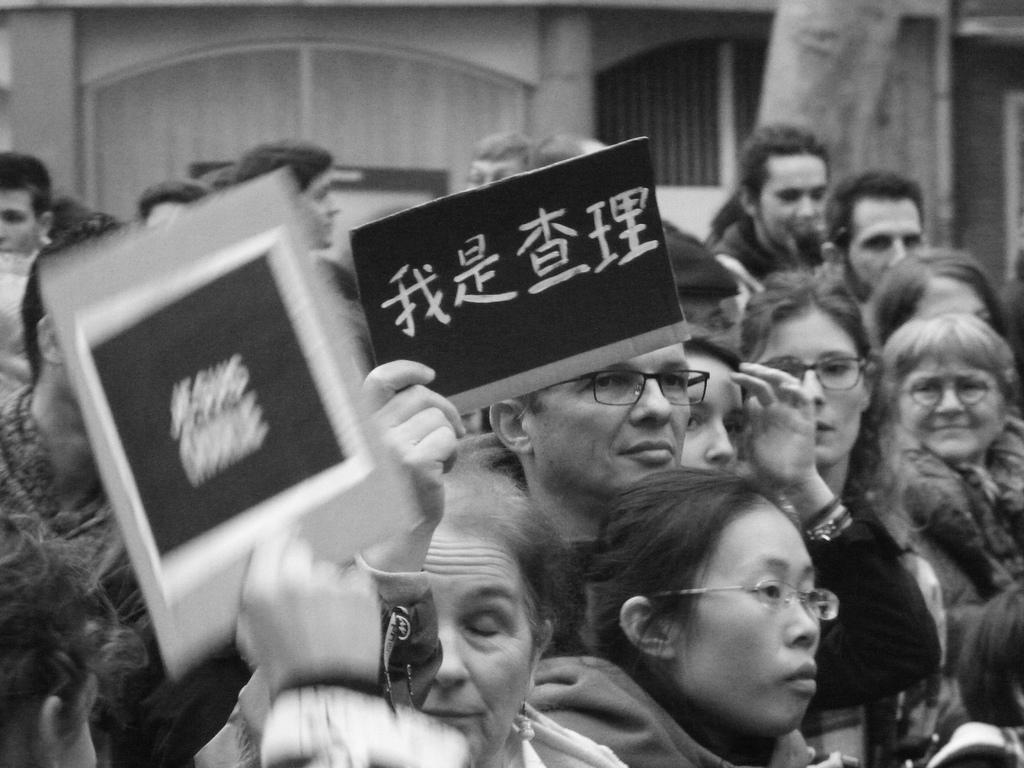Who or what is present in the image? There are people in the image. What else can be seen in the image besides the people? There are boards with text in the image. What is the color scheme of the image? The image is in black and white color. How much salt is visible on the boards in the image? There is no salt present on the boards in the image. How many visitors are in the image? The provided facts do not mention any visitors, only people. 